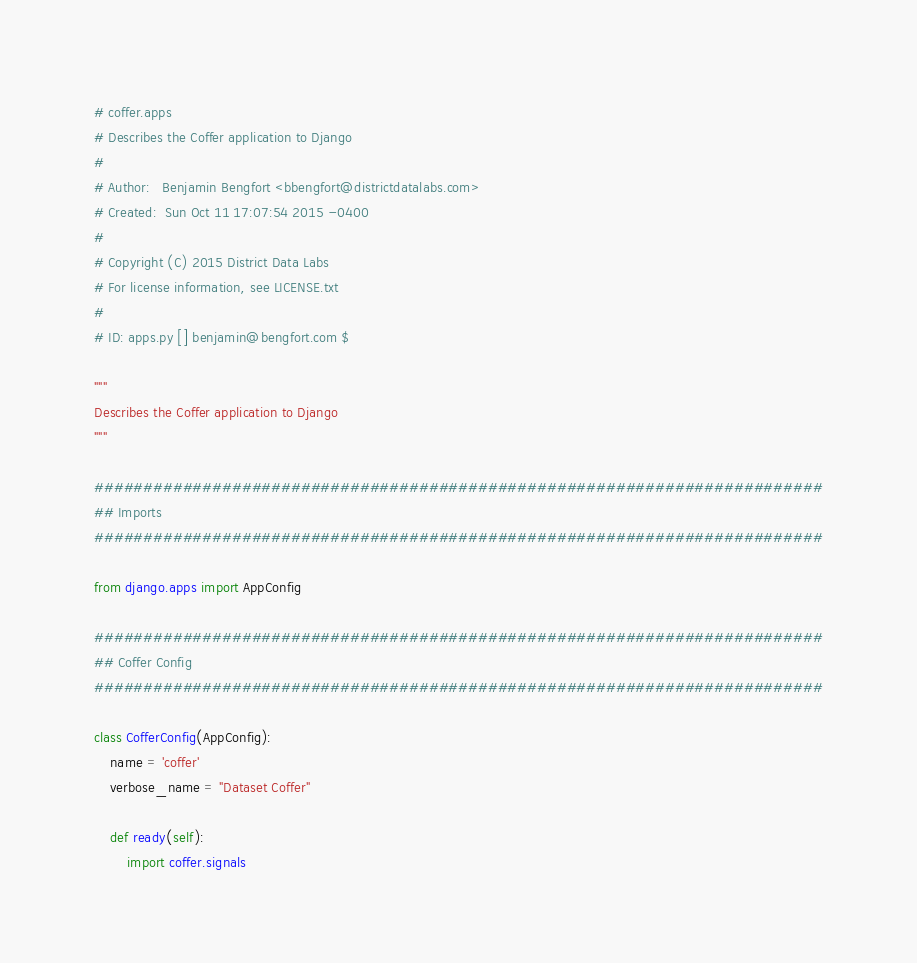<code> <loc_0><loc_0><loc_500><loc_500><_Python_># coffer.apps
# Describes the Coffer application to Django
#
# Author:   Benjamin Bengfort <bbengfort@districtdatalabs.com>
# Created:  Sun Oct 11 17:07:54 2015 -0400
#
# Copyright (C) 2015 District Data Labs
# For license information, see LICENSE.txt
#
# ID: apps.py [] benjamin@bengfort.com $

"""
Describes the Coffer application to Django
"""

##########################################################################
## Imports
##########################################################################

from django.apps import AppConfig

##########################################################################
## Coffer Config
##########################################################################

class CofferConfig(AppConfig):
    name = 'coffer'
    verbose_name = "Dataset Coffer"

    def ready(self):
        import coffer.signals
</code> 